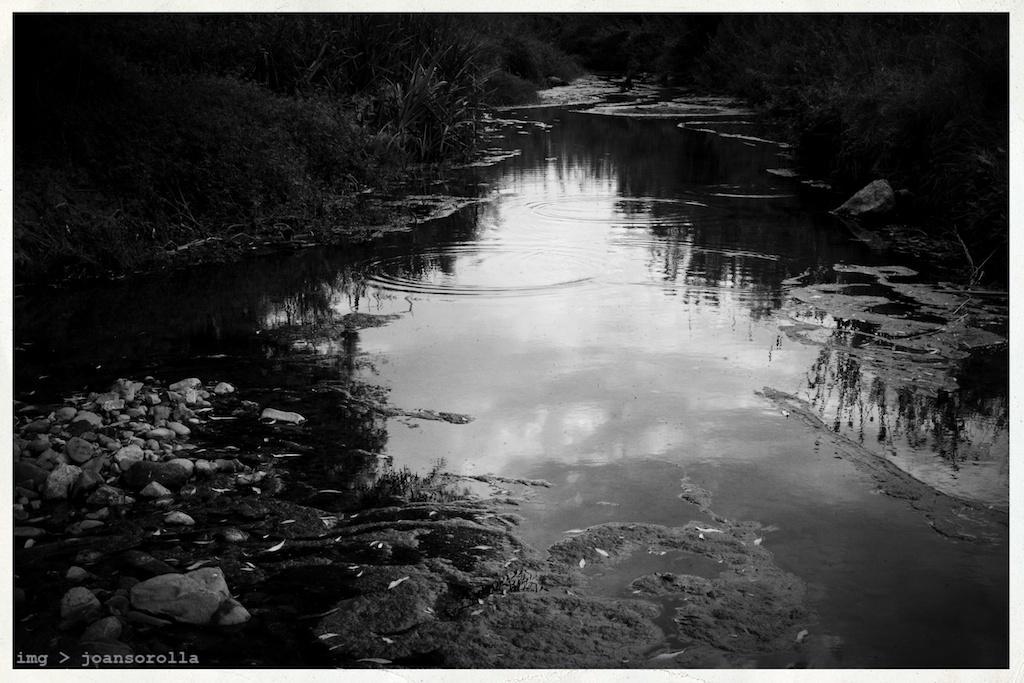In one or two sentences, can you explain what this image depicts? In this picture we can see few plants on right and left side of the image. We can see few covers in water on bottom left. 